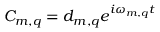Convert formula to latex. <formula><loc_0><loc_0><loc_500><loc_500>C _ { m , q } = d _ { m , q } e ^ { i \omega _ { m , q } t }</formula> 